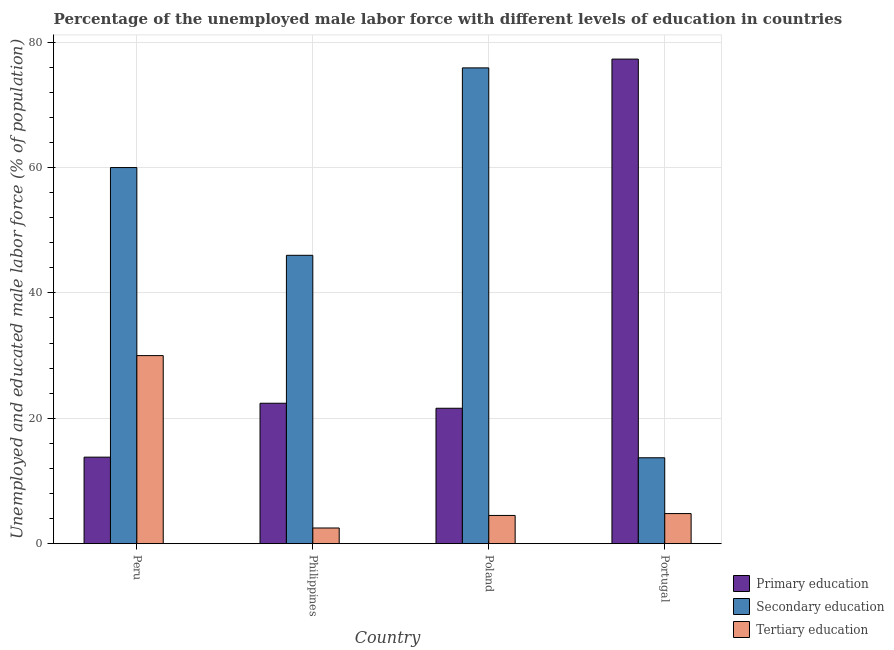How many different coloured bars are there?
Provide a short and direct response. 3. How many groups of bars are there?
Provide a succinct answer. 4. In how many cases, is the number of bars for a given country not equal to the number of legend labels?
Your answer should be compact. 0. What is the percentage of male labor force who received primary education in Peru?
Give a very brief answer. 13.8. Across all countries, what is the maximum percentage of male labor force who received secondary education?
Provide a short and direct response. 75.9. Across all countries, what is the minimum percentage of male labor force who received primary education?
Your response must be concise. 13.8. What is the total percentage of male labor force who received secondary education in the graph?
Your answer should be very brief. 195.6. What is the difference between the percentage of male labor force who received primary education in Peru and that in Poland?
Offer a very short reply. -7.8. What is the difference between the percentage of male labor force who received secondary education in Poland and the percentage of male labor force who received primary education in Peru?
Your response must be concise. 62.1. What is the average percentage of male labor force who received primary education per country?
Your response must be concise. 33.78. What is the difference between the percentage of male labor force who received tertiary education and percentage of male labor force who received primary education in Philippines?
Your answer should be compact. -19.9. In how many countries, is the percentage of male labor force who received tertiary education greater than 64 %?
Give a very brief answer. 0. What is the ratio of the percentage of male labor force who received primary education in Peru to that in Portugal?
Your answer should be compact. 0.18. What is the difference between the highest and the second highest percentage of male labor force who received secondary education?
Keep it short and to the point. 15.9. What is the difference between the highest and the lowest percentage of male labor force who received tertiary education?
Offer a very short reply. 27.5. Is the sum of the percentage of male labor force who received secondary education in Philippines and Portugal greater than the maximum percentage of male labor force who received primary education across all countries?
Offer a very short reply. No. What does the 3rd bar from the right in Poland represents?
Keep it short and to the point. Primary education. Is it the case that in every country, the sum of the percentage of male labor force who received primary education and percentage of male labor force who received secondary education is greater than the percentage of male labor force who received tertiary education?
Your answer should be very brief. Yes. Are all the bars in the graph horizontal?
Provide a short and direct response. No. How many countries are there in the graph?
Provide a short and direct response. 4. Are the values on the major ticks of Y-axis written in scientific E-notation?
Make the answer very short. No. Does the graph contain any zero values?
Give a very brief answer. No. Does the graph contain grids?
Your answer should be very brief. Yes. How are the legend labels stacked?
Your answer should be very brief. Vertical. What is the title of the graph?
Your response must be concise. Percentage of the unemployed male labor force with different levels of education in countries. Does "Solid fuel" appear as one of the legend labels in the graph?
Give a very brief answer. No. What is the label or title of the Y-axis?
Make the answer very short. Unemployed and educated male labor force (% of population). What is the Unemployed and educated male labor force (% of population) in Primary education in Peru?
Make the answer very short. 13.8. What is the Unemployed and educated male labor force (% of population) in Tertiary education in Peru?
Ensure brevity in your answer.  30. What is the Unemployed and educated male labor force (% of population) of Primary education in Philippines?
Offer a terse response. 22.4. What is the Unemployed and educated male labor force (% of population) of Tertiary education in Philippines?
Offer a very short reply. 2.5. What is the Unemployed and educated male labor force (% of population) of Primary education in Poland?
Your answer should be very brief. 21.6. What is the Unemployed and educated male labor force (% of population) in Secondary education in Poland?
Keep it short and to the point. 75.9. What is the Unemployed and educated male labor force (% of population) in Tertiary education in Poland?
Your answer should be very brief. 4.5. What is the Unemployed and educated male labor force (% of population) in Primary education in Portugal?
Keep it short and to the point. 77.3. What is the Unemployed and educated male labor force (% of population) in Secondary education in Portugal?
Offer a very short reply. 13.7. What is the Unemployed and educated male labor force (% of population) in Tertiary education in Portugal?
Keep it short and to the point. 4.8. Across all countries, what is the maximum Unemployed and educated male labor force (% of population) in Primary education?
Give a very brief answer. 77.3. Across all countries, what is the maximum Unemployed and educated male labor force (% of population) of Secondary education?
Your answer should be very brief. 75.9. Across all countries, what is the minimum Unemployed and educated male labor force (% of population) in Primary education?
Provide a succinct answer. 13.8. Across all countries, what is the minimum Unemployed and educated male labor force (% of population) in Secondary education?
Offer a terse response. 13.7. Across all countries, what is the minimum Unemployed and educated male labor force (% of population) of Tertiary education?
Offer a very short reply. 2.5. What is the total Unemployed and educated male labor force (% of population) in Primary education in the graph?
Make the answer very short. 135.1. What is the total Unemployed and educated male labor force (% of population) in Secondary education in the graph?
Provide a short and direct response. 195.6. What is the total Unemployed and educated male labor force (% of population) of Tertiary education in the graph?
Ensure brevity in your answer.  41.8. What is the difference between the Unemployed and educated male labor force (% of population) in Primary education in Peru and that in Philippines?
Keep it short and to the point. -8.6. What is the difference between the Unemployed and educated male labor force (% of population) of Secondary education in Peru and that in Philippines?
Make the answer very short. 14. What is the difference between the Unemployed and educated male labor force (% of population) in Primary education in Peru and that in Poland?
Offer a terse response. -7.8. What is the difference between the Unemployed and educated male labor force (% of population) in Secondary education in Peru and that in Poland?
Your response must be concise. -15.9. What is the difference between the Unemployed and educated male labor force (% of population) in Tertiary education in Peru and that in Poland?
Provide a short and direct response. 25.5. What is the difference between the Unemployed and educated male labor force (% of population) in Primary education in Peru and that in Portugal?
Your response must be concise. -63.5. What is the difference between the Unemployed and educated male labor force (% of population) in Secondary education in Peru and that in Portugal?
Your response must be concise. 46.3. What is the difference between the Unemployed and educated male labor force (% of population) of Tertiary education in Peru and that in Portugal?
Keep it short and to the point. 25.2. What is the difference between the Unemployed and educated male labor force (% of population) in Primary education in Philippines and that in Poland?
Keep it short and to the point. 0.8. What is the difference between the Unemployed and educated male labor force (% of population) of Secondary education in Philippines and that in Poland?
Keep it short and to the point. -29.9. What is the difference between the Unemployed and educated male labor force (% of population) in Primary education in Philippines and that in Portugal?
Ensure brevity in your answer.  -54.9. What is the difference between the Unemployed and educated male labor force (% of population) in Secondary education in Philippines and that in Portugal?
Provide a succinct answer. 32.3. What is the difference between the Unemployed and educated male labor force (% of population) of Primary education in Poland and that in Portugal?
Your answer should be very brief. -55.7. What is the difference between the Unemployed and educated male labor force (% of population) in Secondary education in Poland and that in Portugal?
Keep it short and to the point. 62.2. What is the difference between the Unemployed and educated male labor force (% of population) in Tertiary education in Poland and that in Portugal?
Your answer should be compact. -0.3. What is the difference between the Unemployed and educated male labor force (% of population) of Primary education in Peru and the Unemployed and educated male labor force (% of population) of Secondary education in Philippines?
Provide a succinct answer. -32.2. What is the difference between the Unemployed and educated male labor force (% of population) in Primary education in Peru and the Unemployed and educated male labor force (% of population) in Tertiary education in Philippines?
Offer a terse response. 11.3. What is the difference between the Unemployed and educated male labor force (% of population) in Secondary education in Peru and the Unemployed and educated male labor force (% of population) in Tertiary education in Philippines?
Keep it short and to the point. 57.5. What is the difference between the Unemployed and educated male labor force (% of population) in Primary education in Peru and the Unemployed and educated male labor force (% of population) in Secondary education in Poland?
Ensure brevity in your answer.  -62.1. What is the difference between the Unemployed and educated male labor force (% of population) of Primary education in Peru and the Unemployed and educated male labor force (% of population) of Tertiary education in Poland?
Your answer should be compact. 9.3. What is the difference between the Unemployed and educated male labor force (% of population) of Secondary education in Peru and the Unemployed and educated male labor force (% of population) of Tertiary education in Poland?
Offer a very short reply. 55.5. What is the difference between the Unemployed and educated male labor force (% of population) in Secondary education in Peru and the Unemployed and educated male labor force (% of population) in Tertiary education in Portugal?
Offer a very short reply. 55.2. What is the difference between the Unemployed and educated male labor force (% of population) of Primary education in Philippines and the Unemployed and educated male labor force (% of population) of Secondary education in Poland?
Offer a terse response. -53.5. What is the difference between the Unemployed and educated male labor force (% of population) of Secondary education in Philippines and the Unemployed and educated male labor force (% of population) of Tertiary education in Poland?
Provide a succinct answer. 41.5. What is the difference between the Unemployed and educated male labor force (% of population) of Primary education in Philippines and the Unemployed and educated male labor force (% of population) of Secondary education in Portugal?
Keep it short and to the point. 8.7. What is the difference between the Unemployed and educated male labor force (% of population) in Primary education in Philippines and the Unemployed and educated male labor force (% of population) in Tertiary education in Portugal?
Provide a succinct answer. 17.6. What is the difference between the Unemployed and educated male labor force (% of population) in Secondary education in Philippines and the Unemployed and educated male labor force (% of population) in Tertiary education in Portugal?
Your answer should be compact. 41.2. What is the difference between the Unemployed and educated male labor force (% of population) in Primary education in Poland and the Unemployed and educated male labor force (% of population) in Tertiary education in Portugal?
Offer a terse response. 16.8. What is the difference between the Unemployed and educated male labor force (% of population) of Secondary education in Poland and the Unemployed and educated male labor force (% of population) of Tertiary education in Portugal?
Your response must be concise. 71.1. What is the average Unemployed and educated male labor force (% of population) of Primary education per country?
Offer a very short reply. 33.77. What is the average Unemployed and educated male labor force (% of population) in Secondary education per country?
Your response must be concise. 48.9. What is the average Unemployed and educated male labor force (% of population) of Tertiary education per country?
Your answer should be compact. 10.45. What is the difference between the Unemployed and educated male labor force (% of population) in Primary education and Unemployed and educated male labor force (% of population) in Secondary education in Peru?
Offer a terse response. -46.2. What is the difference between the Unemployed and educated male labor force (% of population) of Primary education and Unemployed and educated male labor force (% of population) of Tertiary education in Peru?
Offer a terse response. -16.2. What is the difference between the Unemployed and educated male labor force (% of population) of Secondary education and Unemployed and educated male labor force (% of population) of Tertiary education in Peru?
Offer a very short reply. 30. What is the difference between the Unemployed and educated male labor force (% of population) in Primary education and Unemployed and educated male labor force (% of population) in Secondary education in Philippines?
Give a very brief answer. -23.6. What is the difference between the Unemployed and educated male labor force (% of population) of Primary education and Unemployed and educated male labor force (% of population) of Tertiary education in Philippines?
Give a very brief answer. 19.9. What is the difference between the Unemployed and educated male labor force (% of population) of Secondary education and Unemployed and educated male labor force (% of population) of Tertiary education in Philippines?
Offer a very short reply. 43.5. What is the difference between the Unemployed and educated male labor force (% of population) of Primary education and Unemployed and educated male labor force (% of population) of Secondary education in Poland?
Offer a very short reply. -54.3. What is the difference between the Unemployed and educated male labor force (% of population) of Primary education and Unemployed and educated male labor force (% of population) of Tertiary education in Poland?
Your answer should be very brief. 17.1. What is the difference between the Unemployed and educated male labor force (% of population) of Secondary education and Unemployed and educated male labor force (% of population) of Tertiary education in Poland?
Provide a short and direct response. 71.4. What is the difference between the Unemployed and educated male labor force (% of population) of Primary education and Unemployed and educated male labor force (% of population) of Secondary education in Portugal?
Offer a terse response. 63.6. What is the difference between the Unemployed and educated male labor force (% of population) of Primary education and Unemployed and educated male labor force (% of population) of Tertiary education in Portugal?
Ensure brevity in your answer.  72.5. What is the difference between the Unemployed and educated male labor force (% of population) of Secondary education and Unemployed and educated male labor force (% of population) of Tertiary education in Portugal?
Your response must be concise. 8.9. What is the ratio of the Unemployed and educated male labor force (% of population) in Primary education in Peru to that in Philippines?
Make the answer very short. 0.62. What is the ratio of the Unemployed and educated male labor force (% of population) in Secondary education in Peru to that in Philippines?
Ensure brevity in your answer.  1.3. What is the ratio of the Unemployed and educated male labor force (% of population) of Primary education in Peru to that in Poland?
Ensure brevity in your answer.  0.64. What is the ratio of the Unemployed and educated male labor force (% of population) in Secondary education in Peru to that in Poland?
Your answer should be compact. 0.79. What is the ratio of the Unemployed and educated male labor force (% of population) of Primary education in Peru to that in Portugal?
Offer a terse response. 0.18. What is the ratio of the Unemployed and educated male labor force (% of population) of Secondary education in Peru to that in Portugal?
Provide a succinct answer. 4.38. What is the ratio of the Unemployed and educated male labor force (% of population) in Tertiary education in Peru to that in Portugal?
Give a very brief answer. 6.25. What is the ratio of the Unemployed and educated male labor force (% of population) in Secondary education in Philippines to that in Poland?
Give a very brief answer. 0.61. What is the ratio of the Unemployed and educated male labor force (% of population) of Tertiary education in Philippines to that in Poland?
Your answer should be very brief. 0.56. What is the ratio of the Unemployed and educated male labor force (% of population) of Primary education in Philippines to that in Portugal?
Offer a terse response. 0.29. What is the ratio of the Unemployed and educated male labor force (% of population) in Secondary education in Philippines to that in Portugal?
Keep it short and to the point. 3.36. What is the ratio of the Unemployed and educated male labor force (% of population) of Tertiary education in Philippines to that in Portugal?
Give a very brief answer. 0.52. What is the ratio of the Unemployed and educated male labor force (% of population) in Primary education in Poland to that in Portugal?
Make the answer very short. 0.28. What is the ratio of the Unemployed and educated male labor force (% of population) of Secondary education in Poland to that in Portugal?
Provide a short and direct response. 5.54. What is the ratio of the Unemployed and educated male labor force (% of population) of Tertiary education in Poland to that in Portugal?
Your answer should be compact. 0.94. What is the difference between the highest and the second highest Unemployed and educated male labor force (% of population) of Primary education?
Your answer should be very brief. 54.9. What is the difference between the highest and the second highest Unemployed and educated male labor force (% of population) in Tertiary education?
Ensure brevity in your answer.  25.2. What is the difference between the highest and the lowest Unemployed and educated male labor force (% of population) of Primary education?
Offer a very short reply. 63.5. What is the difference between the highest and the lowest Unemployed and educated male labor force (% of population) in Secondary education?
Your answer should be compact. 62.2. What is the difference between the highest and the lowest Unemployed and educated male labor force (% of population) in Tertiary education?
Keep it short and to the point. 27.5. 